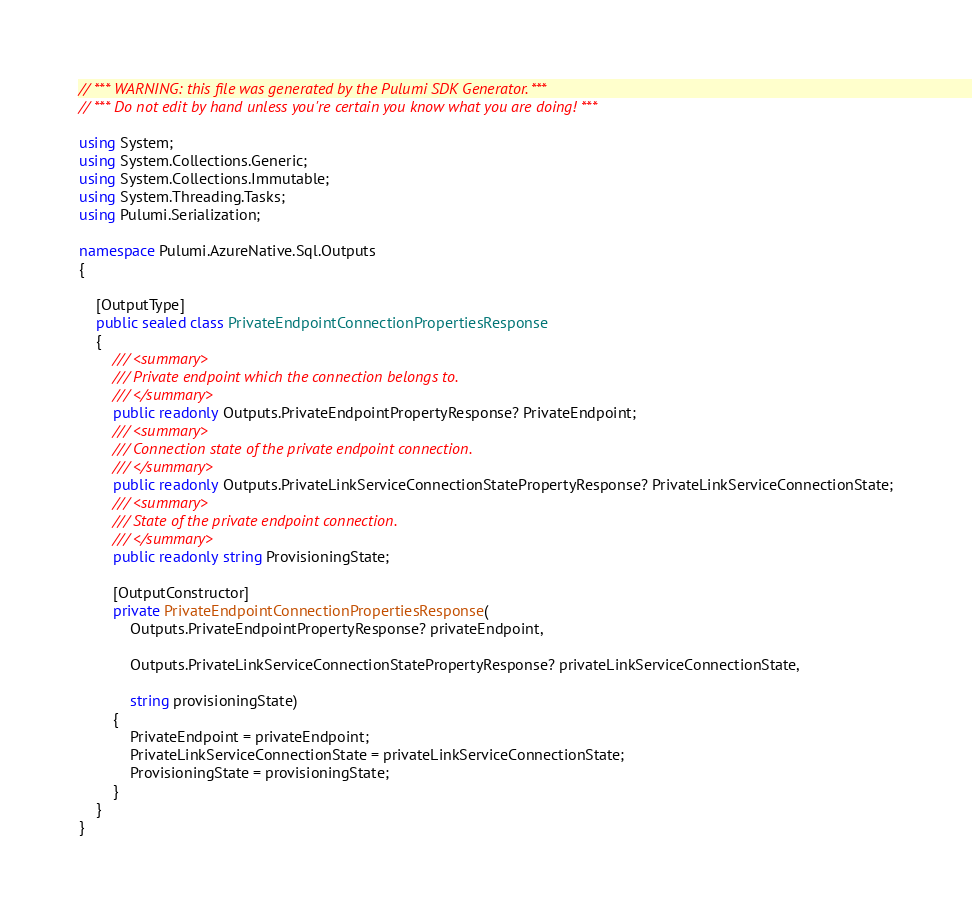Convert code to text. <code><loc_0><loc_0><loc_500><loc_500><_C#_>// *** WARNING: this file was generated by the Pulumi SDK Generator. ***
// *** Do not edit by hand unless you're certain you know what you are doing! ***

using System;
using System.Collections.Generic;
using System.Collections.Immutable;
using System.Threading.Tasks;
using Pulumi.Serialization;

namespace Pulumi.AzureNative.Sql.Outputs
{

    [OutputType]
    public sealed class PrivateEndpointConnectionPropertiesResponse
    {
        /// <summary>
        /// Private endpoint which the connection belongs to.
        /// </summary>
        public readonly Outputs.PrivateEndpointPropertyResponse? PrivateEndpoint;
        /// <summary>
        /// Connection state of the private endpoint connection.
        /// </summary>
        public readonly Outputs.PrivateLinkServiceConnectionStatePropertyResponse? PrivateLinkServiceConnectionState;
        /// <summary>
        /// State of the private endpoint connection.
        /// </summary>
        public readonly string ProvisioningState;

        [OutputConstructor]
        private PrivateEndpointConnectionPropertiesResponse(
            Outputs.PrivateEndpointPropertyResponse? privateEndpoint,

            Outputs.PrivateLinkServiceConnectionStatePropertyResponse? privateLinkServiceConnectionState,

            string provisioningState)
        {
            PrivateEndpoint = privateEndpoint;
            PrivateLinkServiceConnectionState = privateLinkServiceConnectionState;
            ProvisioningState = provisioningState;
        }
    }
}
</code> 